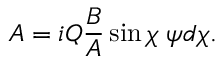Convert formula to latex. <formula><loc_0><loc_0><loc_500><loc_500>A = i Q \frac { B } { A } \sin \chi \, \psi d \chi .</formula> 